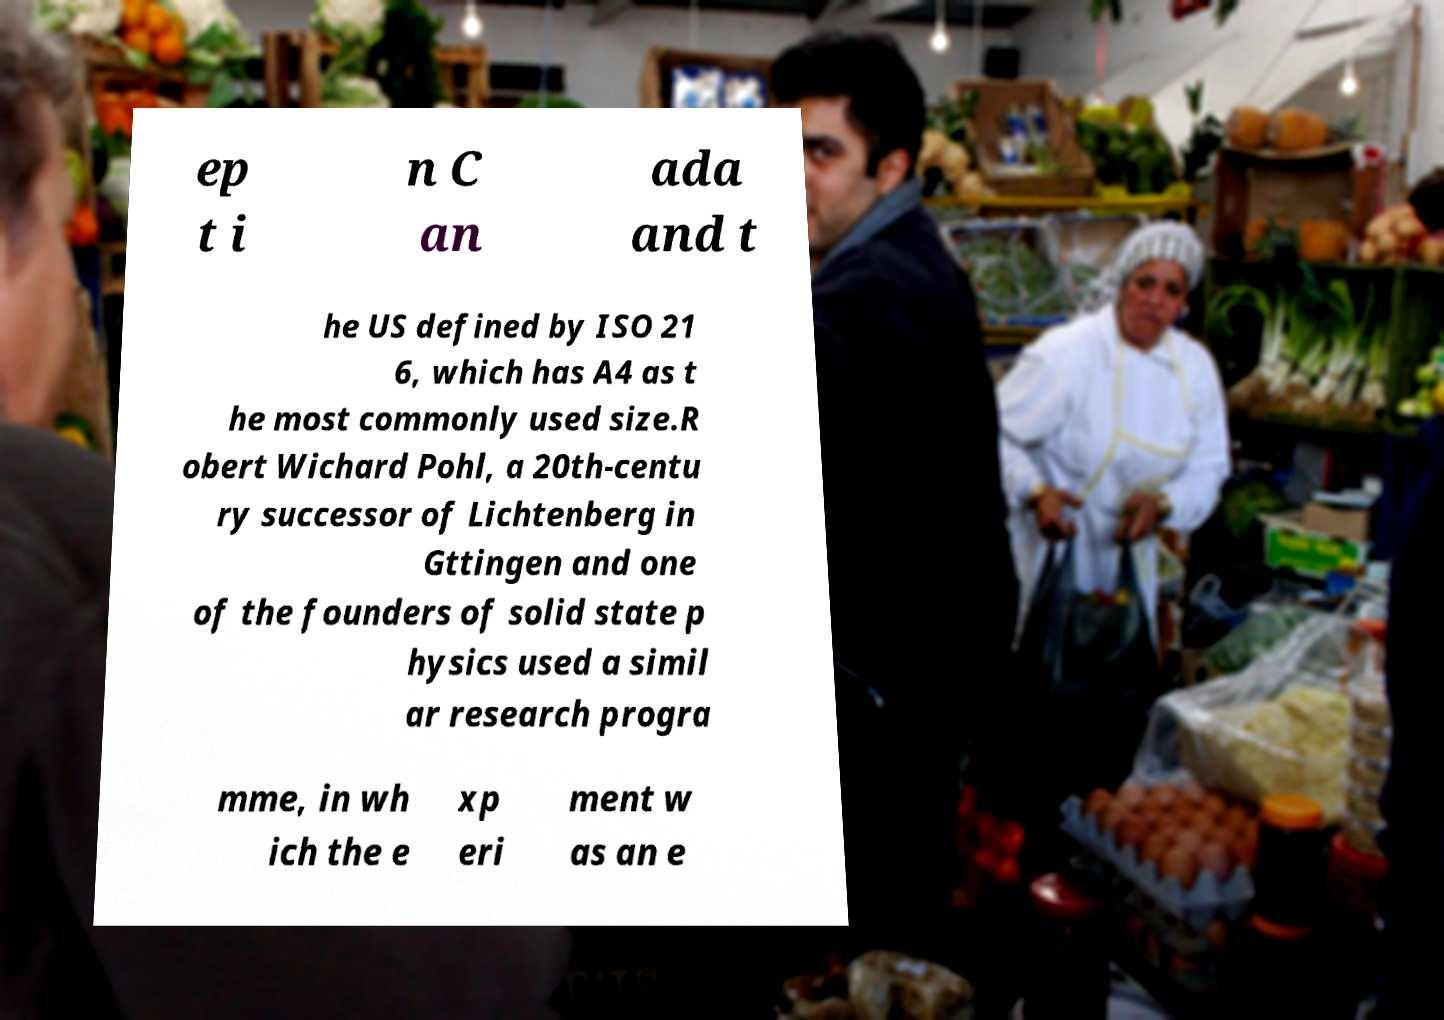What messages or text are displayed in this image? I need them in a readable, typed format. ep t i n C an ada and t he US defined by ISO 21 6, which has A4 as t he most commonly used size.R obert Wichard Pohl, a 20th-centu ry successor of Lichtenberg in Gttingen and one of the founders of solid state p hysics used a simil ar research progra mme, in wh ich the e xp eri ment w as an e 